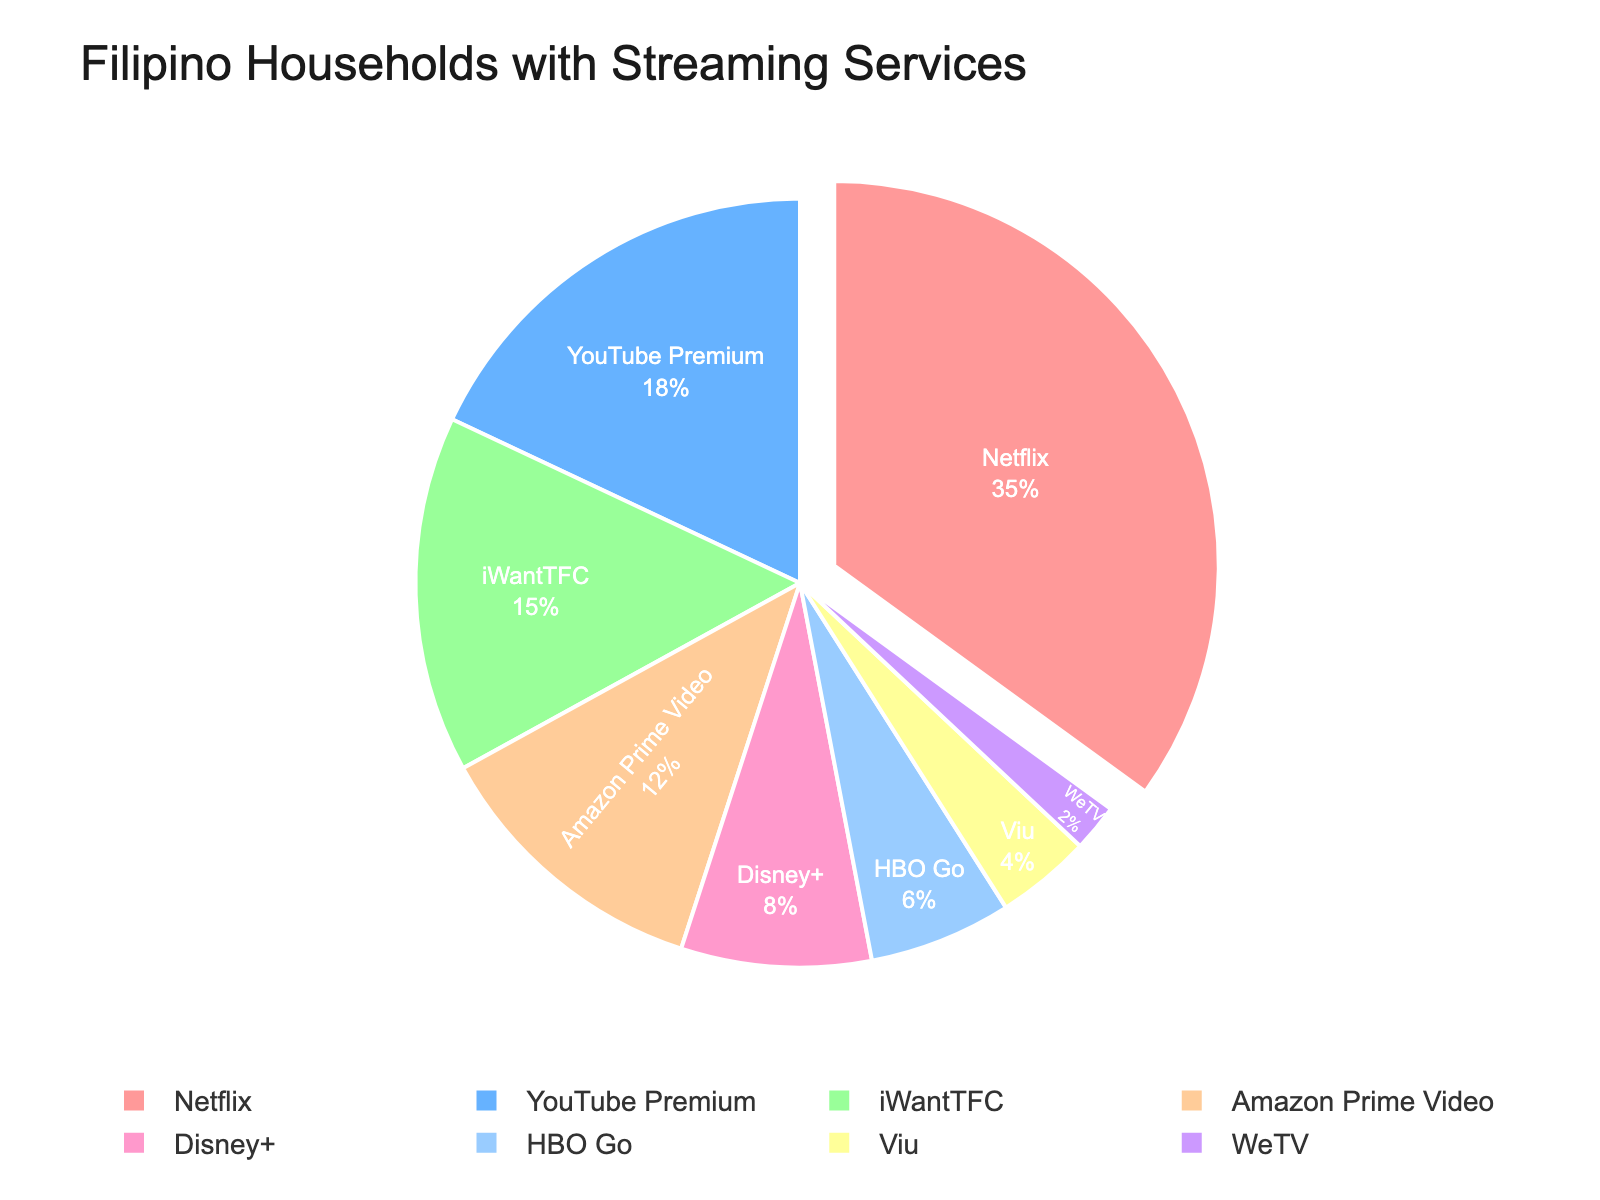Which streaming service has the highest percentage of Filipino households with access? The streaming service with the largest section of the pie chart, which appears pulled slightly outwards, has the highest percentage.
Answer: Netflix How many streaming services have a percentage of 15% or more? Visual inspection of the pie chart shows that Netflix, YouTube Premium, and iWantTFC each have a segment labeled with 15% or more.
Answer: 3 What is the difference between the percentages of Netflix and Amazon Prime Video users? Netflix is 35% and Amazon Prime Video is 12%. Subtract 12 from 35 to find the difference.
Answer: 23% Does HBO Go have a higher or lower percentage than Disney+? By looking at the pie chart, it's clear that HBO Go has a smaller slice of the pie compared to Disney+.
Answer: Lower Combine the percentages of YouTube Premium, iWantTFC, and Disney+. What is their total percentage? YouTube Premium is 18%, iWantTFC is 15%, and Disney+ is 8%. Add these values together: 18% + 15% + 8% = 41%.
Answer: 41% Among the streaming services listed, which one has the least number of Filipino households with access? By examining the smallest slice of the pie chart, the service shown as 2% is the least.
Answer: WeTV How does the percentage of Viu compare to that of HBO Go? The pie chart indicates Viu at 4% and HBO Go at 6%. So Viu is less than HBO Go.
Answer: Less than What percentage of Filipino households have access to services other than Netflix and YouTube Premium? Sum the percentages of iWantTFC, Amazon Prime Video, Disney+, HBO Go, Viu, and WeTV: 15% + 12% + 8% + 6% + 4% + 2% = 47%.
Answer: 47% How many services have less than 10% household access? The services with segments less than 10% are Disney+, HBO Go, Viu, and WeTV. Count these segments.
Answer: 4 If you combine the percentages of the three least popular services, what percentage do you get? The three least popular services are Viu (4%), WeTV (2%), and HBO Go (6%). Add these values: 4% + 2% + 6% = 12%.
Answer: 12% 